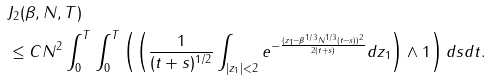Convert formula to latex. <formula><loc_0><loc_0><loc_500><loc_500>& J _ { 2 } ( \beta , N , T ) \\ & \leq C N ^ { 2 } \int _ { 0 } ^ { T } \int _ { 0 } ^ { T } \left ( \left ( \frac { 1 } { ( t + s ) ^ { 1 / 2 } } \int _ { | z _ { 1 } | < 2 } e ^ { - \frac { ( z _ { 1 } - \beta ^ { 1 / 3 } N ^ { 1 / 3 } ( t - s ) ) ^ { 2 } } { 2 ( t + s ) } } d z _ { 1 } \right ) \wedge 1 \right ) d s d t .</formula> 